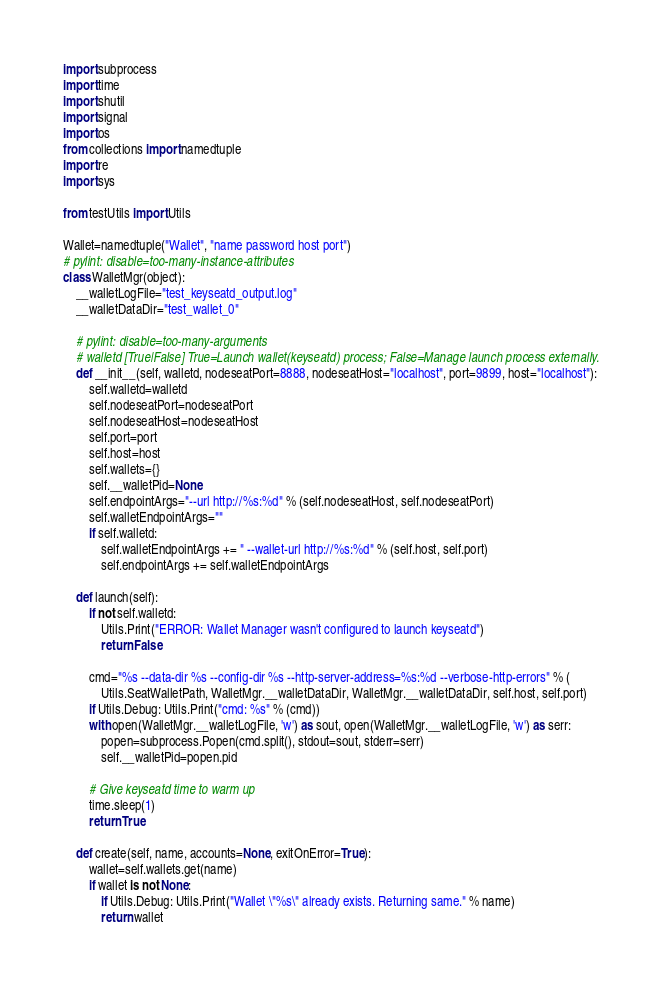Convert code to text. <code><loc_0><loc_0><loc_500><loc_500><_Python_>import subprocess
import time
import shutil
import signal
import os
from collections import namedtuple
import re
import sys

from testUtils import Utils

Wallet=namedtuple("Wallet", "name password host port")
# pylint: disable=too-many-instance-attributes
class WalletMgr(object):
    __walletLogFile="test_keyseatd_output.log"
    __walletDataDir="test_wallet_0"

    # pylint: disable=too-many-arguments
    # walletd [True|False] True=Launch wallet(keyseatd) process; False=Manage launch process externally.
    def __init__(self, walletd, nodeseatPort=8888, nodeseatHost="localhost", port=9899, host="localhost"):
        self.walletd=walletd
        self.nodeseatPort=nodeseatPort
        self.nodeseatHost=nodeseatHost
        self.port=port
        self.host=host
        self.wallets={}
        self.__walletPid=None
        self.endpointArgs="--url http://%s:%d" % (self.nodeseatHost, self.nodeseatPort)
        self.walletEndpointArgs=""
        if self.walletd:
            self.walletEndpointArgs += " --wallet-url http://%s:%d" % (self.host, self.port)
            self.endpointArgs += self.walletEndpointArgs

    def launch(self):
        if not self.walletd:
            Utils.Print("ERROR: Wallet Manager wasn't configured to launch keyseatd")
            return False

        cmd="%s --data-dir %s --config-dir %s --http-server-address=%s:%d --verbose-http-errors" % (
            Utils.SeatWalletPath, WalletMgr.__walletDataDir, WalletMgr.__walletDataDir, self.host, self.port)
        if Utils.Debug: Utils.Print("cmd: %s" % (cmd))
        with open(WalletMgr.__walletLogFile, 'w') as sout, open(WalletMgr.__walletLogFile, 'w') as serr:
            popen=subprocess.Popen(cmd.split(), stdout=sout, stderr=serr)
            self.__walletPid=popen.pid

        # Give keyseatd time to warm up
        time.sleep(1)
        return True

    def create(self, name, accounts=None, exitOnError=True):
        wallet=self.wallets.get(name)
        if wallet is not None:
            if Utils.Debug: Utils.Print("Wallet \"%s\" already exists. Returning same." % name)
            return wallet</code> 